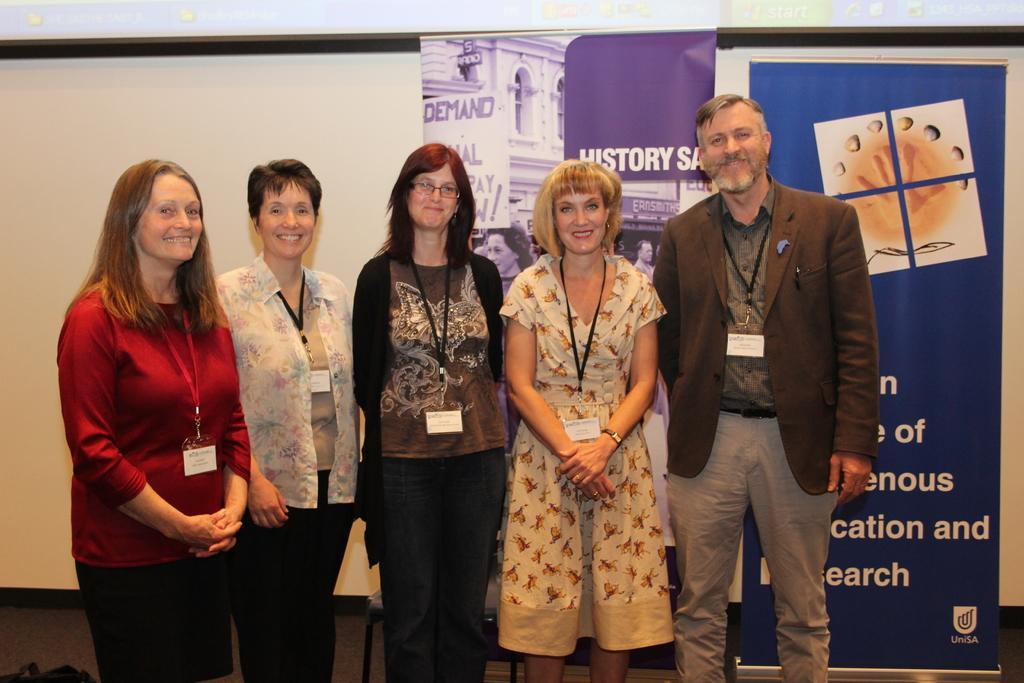How would you summarize this image in a sentence or two? In this picture we can see five people wore id cards, smiling, standing and in the background we can see the wall, chair and banners. 